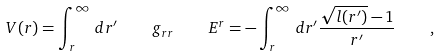Convert formula to latex. <formula><loc_0><loc_0><loc_500><loc_500>V ( r ) = \int _ { r } ^ { \infty } \, d r ^ { \prime } \, \quad g _ { r r } \, \quad E ^ { r } = - \int _ { r } ^ { \infty } \, d r ^ { \prime } \frac { \sqrt { l ( r ^ { \prime } ) } - 1 } { r ^ { \prime } } \, \quad ,</formula> 